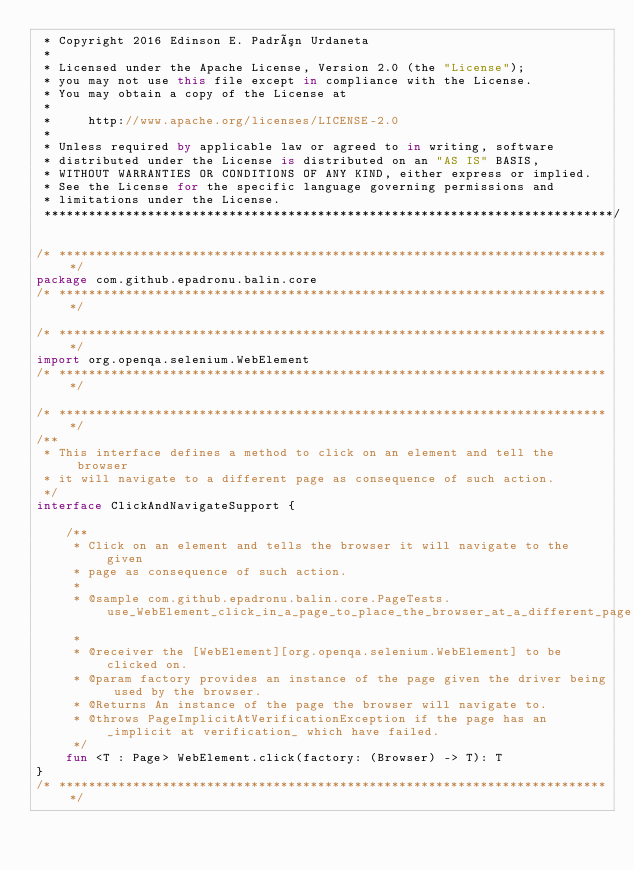Convert code to text. <code><loc_0><loc_0><loc_500><loc_500><_Kotlin_> * Copyright 2016 Edinson E. Padrón Urdaneta
 *
 * Licensed under the Apache License, Version 2.0 (the "License");
 * you may not use this file except in compliance with the License.
 * You may obtain a copy of the License at
 *
 *     http://www.apache.org/licenses/LICENSE-2.0
 *
 * Unless required by applicable law or agreed to in writing, software
 * distributed under the License is distributed on an "AS IS" BASIS,
 * WITHOUT WARRANTIES OR CONDITIONS OF ANY KIND, either express or implied.
 * See the License for the specific language governing permissions and
 * limitations under the License.
 *****************************************************************************/

/* ***************************************************************************/
package com.github.epadronu.balin.core
/* ***************************************************************************/

/* ***************************************************************************/
import org.openqa.selenium.WebElement
/* ***************************************************************************/

/* ***************************************************************************/
/**
 * This interface defines a method to click on an element and tell the browser
 * it will navigate to a different page as consequence of such action.
 */
interface ClickAndNavigateSupport {

    /**
     * Click on an element and tells the browser it will navigate to the given
     * page as consequence of such action.
     *
     * @sample com.github.epadronu.balin.core.PageTests.use_WebElement_click_in_a_page_to_place_the_browser_at_a_different_page
     *
     * @receiver the [WebElement][org.openqa.selenium.WebElement] to be clicked on.
     * @param factory provides an instance of the page given the driver being used by the browser.
     * @Returns An instance of the page the browser will navigate to.
     * @throws PageImplicitAtVerificationException if the page has an _implicit at verification_ which have failed.
     */
    fun <T : Page> WebElement.click(factory: (Browser) -> T): T
}
/* ***************************************************************************/
</code> 